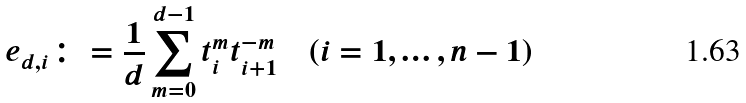Convert formula to latex. <formula><loc_0><loc_0><loc_500><loc_500>e _ { d , i } \colon = \frac { 1 } { d } \sum _ { m = 0 } ^ { d - 1 } t _ { i } ^ { m } t _ { i + 1 } ^ { - m } \quad ( i = 1 , \dots , n - 1 )</formula> 